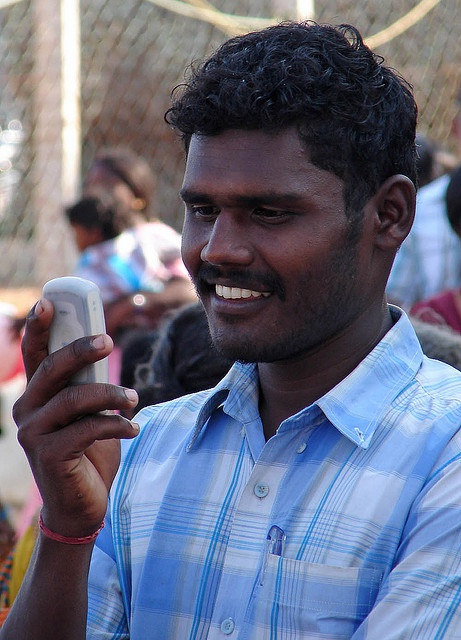Describe the objects in this image and their specific colors. I can see people in white, black, lightblue, and gray tones, people in white, gray, and maroon tones, people in white, darkgray, gray, and lightblue tones, people in white, black, lavender, darkgray, and gray tones, and cell phone in white, darkgray, and gray tones in this image. 